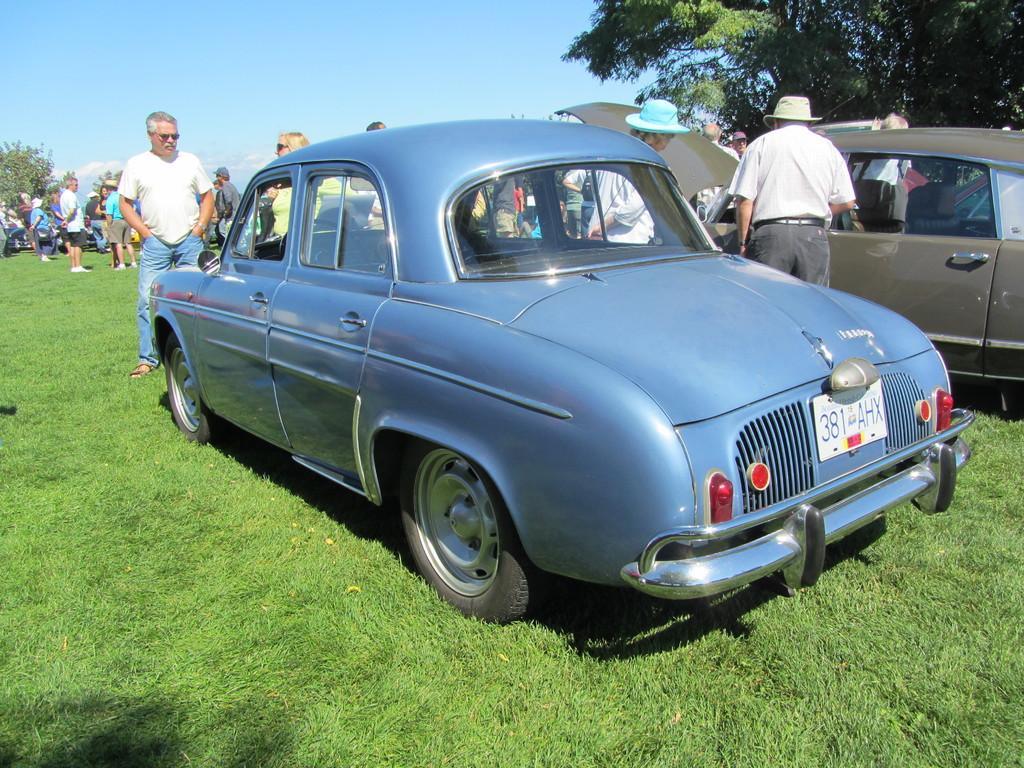Describe this image in one or two sentences. In this image there are cars and we can see people. At the bottom there is grass. In the background there are trees and sky. 